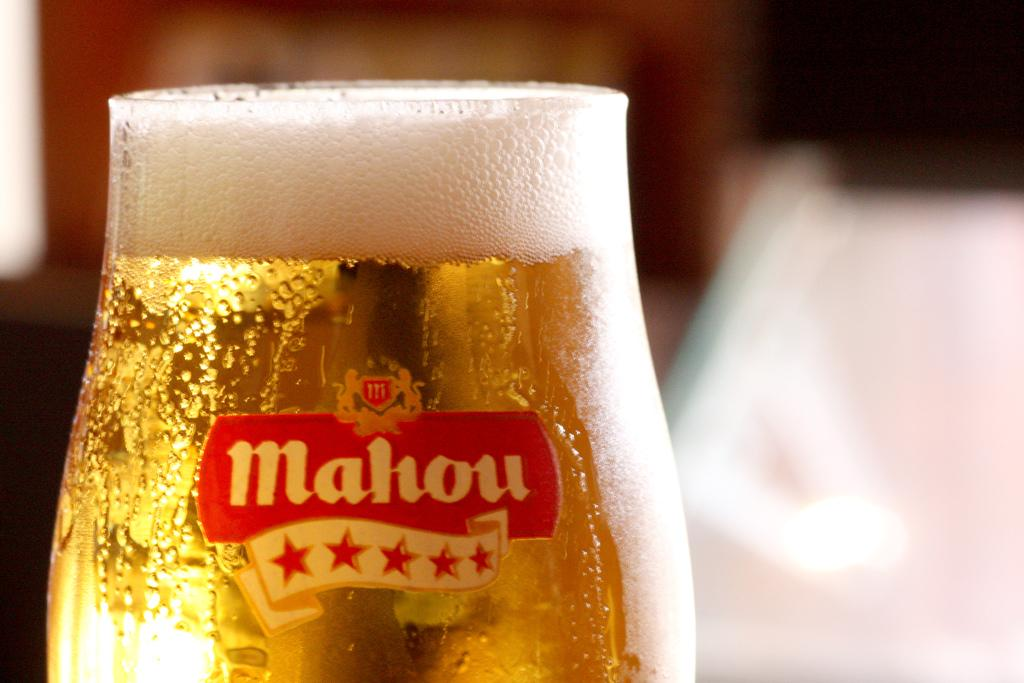<image>
Create a compact narrative representing the image presented. A bottle of Mahou beer poured into a glass chalice. 